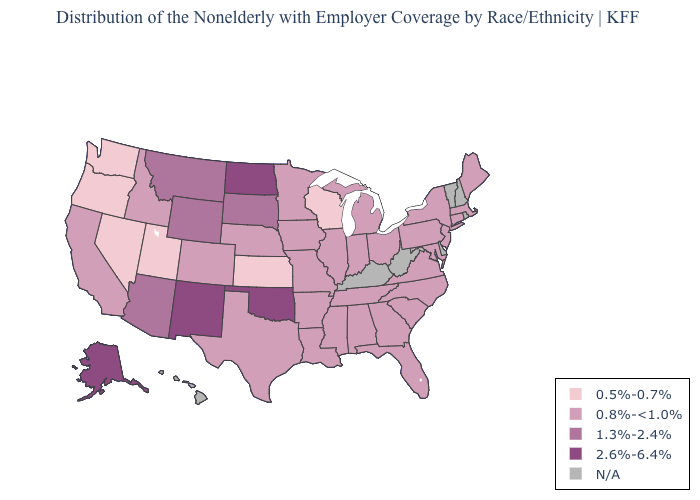Does Colorado have the lowest value in the USA?
Give a very brief answer. No. Name the states that have a value in the range 0.5%-0.7%?
Keep it brief. Kansas, Nevada, Oregon, Utah, Washington, Wisconsin. Name the states that have a value in the range 1.3%-2.4%?
Write a very short answer. Arizona, Montana, South Dakota, Wyoming. What is the highest value in states that border Kentucky?
Answer briefly. 0.8%-<1.0%. What is the value of Texas?
Keep it brief. 0.8%-<1.0%. Does Oklahoma have the lowest value in the South?
Be succinct. No. Which states have the lowest value in the USA?
Answer briefly. Kansas, Nevada, Oregon, Utah, Washington, Wisconsin. What is the value of Florida?
Keep it brief. 0.8%-<1.0%. Name the states that have a value in the range 1.3%-2.4%?
Write a very short answer. Arizona, Montana, South Dakota, Wyoming. Among the states that border Connecticut , which have the lowest value?
Give a very brief answer. Massachusetts, New York. Which states have the lowest value in the USA?
Short answer required. Kansas, Nevada, Oregon, Utah, Washington, Wisconsin. Which states hav the highest value in the Northeast?
Concise answer only. Connecticut, Maine, Massachusetts, New Jersey, New York, Pennsylvania. What is the value of Illinois?
Answer briefly. 0.8%-<1.0%. Does the map have missing data?
Keep it brief. Yes. 